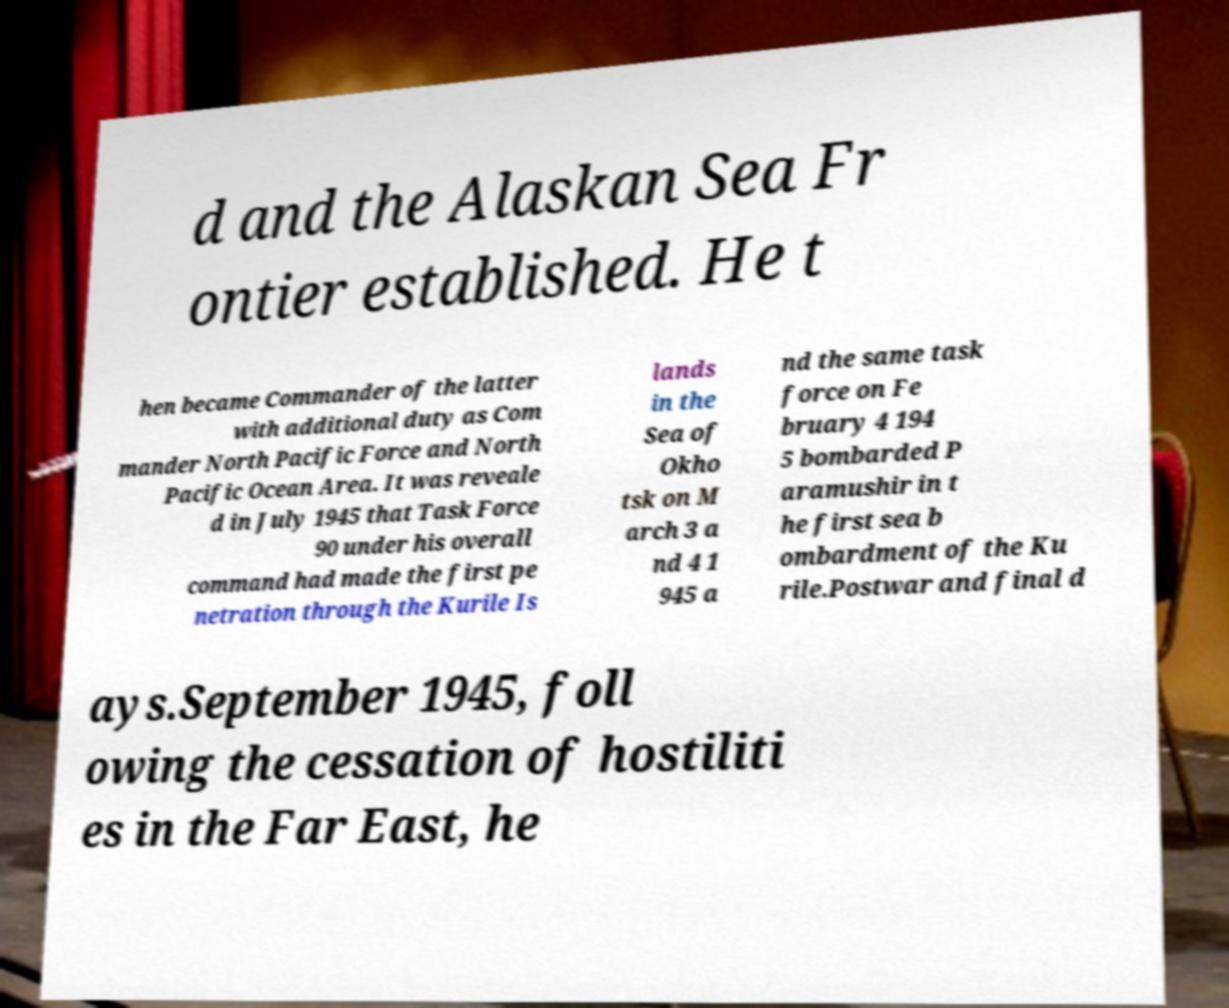Can you read and provide the text displayed in the image?This photo seems to have some interesting text. Can you extract and type it out for me? d and the Alaskan Sea Fr ontier established. He t hen became Commander of the latter with additional duty as Com mander North Pacific Force and North Pacific Ocean Area. It was reveale d in July 1945 that Task Force 90 under his overall command had made the first pe netration through the Kurile Is lands in the Sea of Okho tsk on M arch 3 a nd 4 1 945 a nd the same task force on Fe bruary 4 194 5 bombarded P aramushir in t he first sea b ombardment of the Ku rile.Postwar and final d ays.September 1945, foll owing the cessation of hostiliti es in the Far East, he 